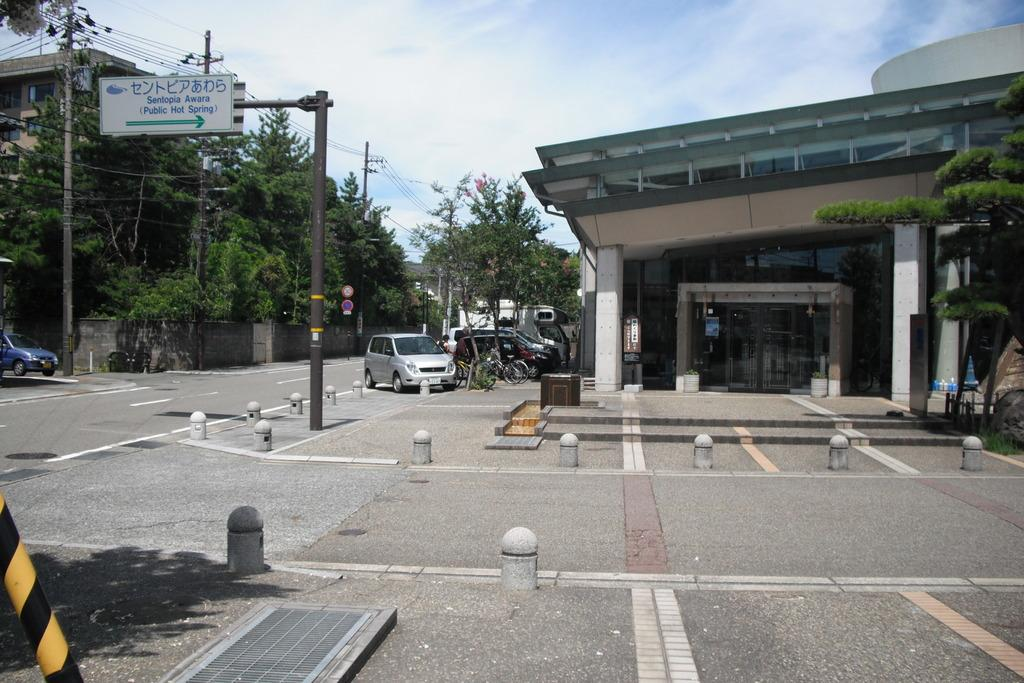What type of vegetation can be seen in the image? There are trees in the image. What type of structures are visible in the image? There are buildings in the image. What vehicles can be seen parked in the image? Cars and bicycles are parked in the image. What type of signage is present in the image? There are sign boards on poles in the image. What type of infrastructure is present in the image? There are electrical poles in the image. How would you describe the sky in the image? The sky is blue and cloudy in the image. What type of basketball game is being played in the image? There is no basketball game present in the image. What type of stew is being served in the image? There is no stew present in the image. 